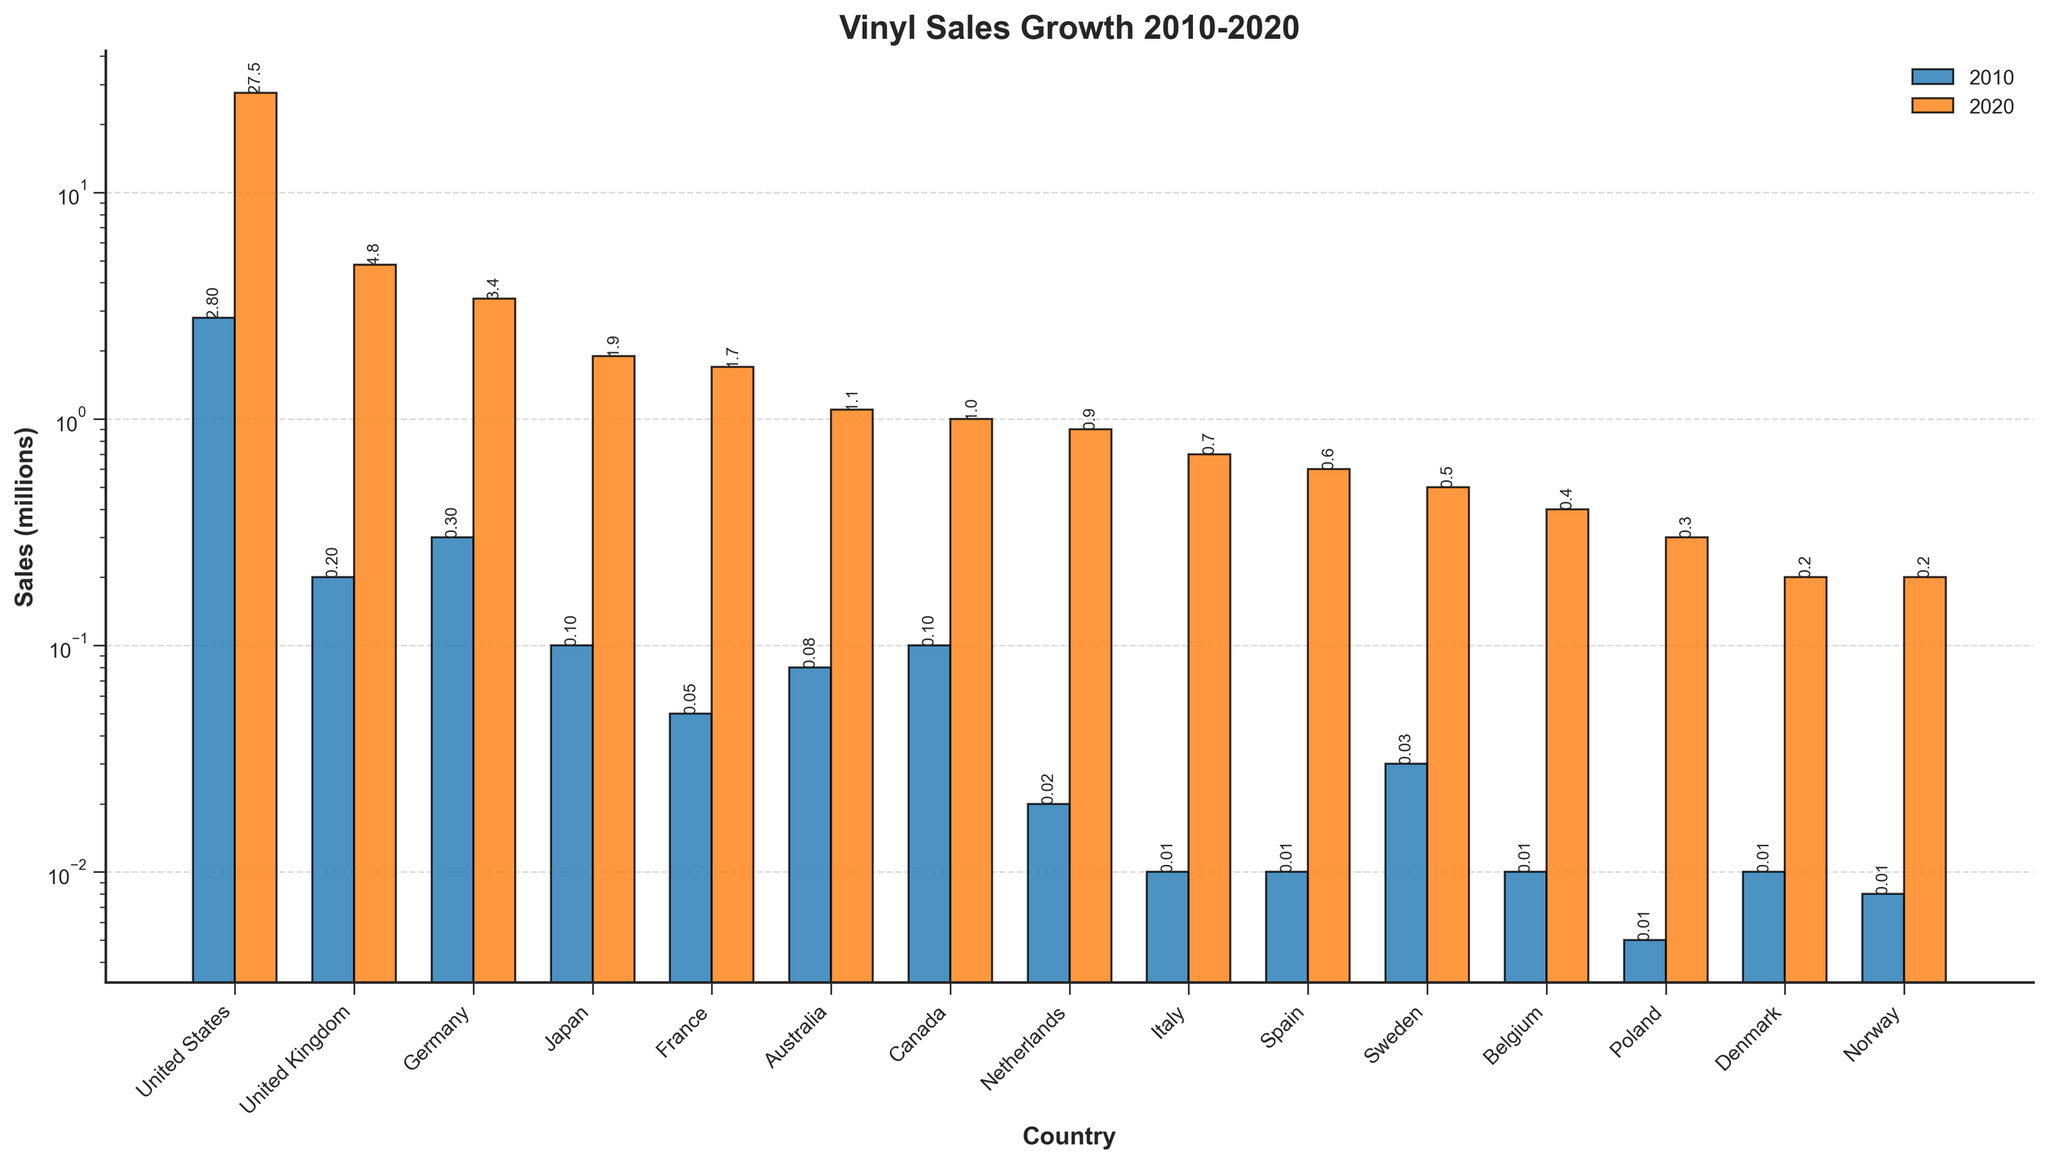Which country had the highest vinyl sales in 2020? The bar corresponding to the year 2020 for each country shows the height of sales. The highest bar in 2020 is for the United States, indicating it had the highest vinyl sales.
Answer: United States Which country had the smallest increase in vinyl sales from 2010 to 2020? To find the smallest increase, subtract the 2010 value from the 2020 value for each country. Denmark increased from 0.01 million to 0.2 million, and Italy increased from 0.01 million to 0.7 million. Among all, Norway went from 0.008 million to 0.2 million, indicating the smallest increase.
Answer: Norway How many times did vinyl sales in Australia increase from 2010 to 2020? Compare the 2010 sales to 2020 sales for Australia. Sales went from 0.08 million in 2010 to 1.1 million in 2020. The increase factor is calculated as 1.1 / 0.08.
Answer: 13.75 Which countries had vinyl sales of less than 1 million in both 2010 and 2020? By looking at both years for each country, the countries with bars that stay below 1 million sales for both years are Spain, Sweden, Belgium, Poland, Denmark, and Norway.
Answer: Spain, Sweden, Belgium, Poland, Denmark, Norway How much did vinyl sales in Japan increase from 2010 to 2020? Subtract the 2010 sales figure for Japan (0.1 million) from the 2020 sales figure (1.9 million). The increase is 1.9 million - 0.1 million.
Answer: 1.8 million Which year (2010 or 2020) looks more colorful in the bar chart? The bars representing the years 2010 and 2020 have distinct colors, blue for 2010 and orange for 2020. Both colors are vibrant, but the taller orange bars in 2020 visually dominate.
Answer: 2020 What is the total vinyl sales in 2020 for United States and United Kingdom combined? Add the 2020 sales figures for United States and United Kingdom. United States sold 27.5 million and the United Kingdom sold 4.8 million. Therefore, 27.5 + 4.8.
Answer: 32.3 million Is the sales growth in the United States between 2010 and 2020 higher than the total sales in all other countries in 2020 combined? Calculate the sales growth in the United States (27.5 - 2.8) which equals 24.7 million. Summing the sales in 2020 for all other countries gives 4.8 + 3.4 + 1.9 + 1.7 + 1.1 + 1.0 + 0.9 + 0.7 + 0.6 + 0.5 + 0.4 + 0.3 + 0.2 + 0.2 = 17.7 million. Since 24.7 is greater than 17.7, the answer is yes.
Answer: Yes Which country had the smallest vinyl sales in 2010? Looking at the smallest bar height among all countries for 2010, the country is Poland with sales of 0.005 million.
Answer: Poland Which countries have seen their vinyl sales increase by over 20 million units from 2010 to 2020? Find the difference between the sales numbers of 2010 and 2020 for each country. Only the United States increased from 2.8 million to 27.5 million, a difference of 24.7 million, which is more than 20 million.
Answer: United States 